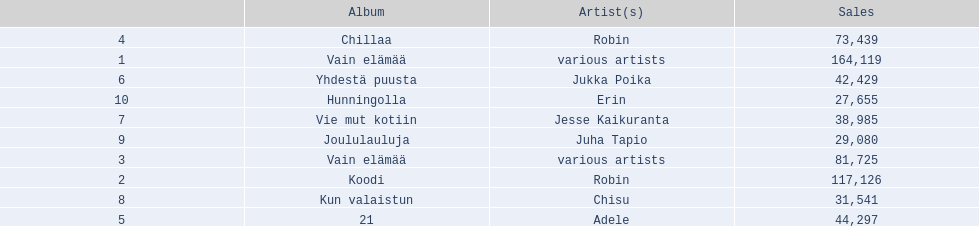Which were the number-one albums of 2012 in finland? Vain elämää, Koodi, Vain elämää, Chillaa, 21, Yhdestä puusta, Vie mut kotiin, Kun valaistun, Joululauluja, Hunningolla. Of those albums, which were by robin? Koodi, Chillaa. Of those albums by robin, which is not chillaa? Koodi. 